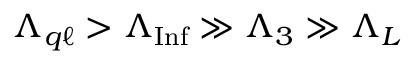Convert formula to latex. <formula><loc_0><loc_0><loc_500><loc_500>\Lambda _ { q \ell } > \Lambda _ { I n f } \gg \Lambda _ { 3 } \gg \Lambda _ { L }</formula> 